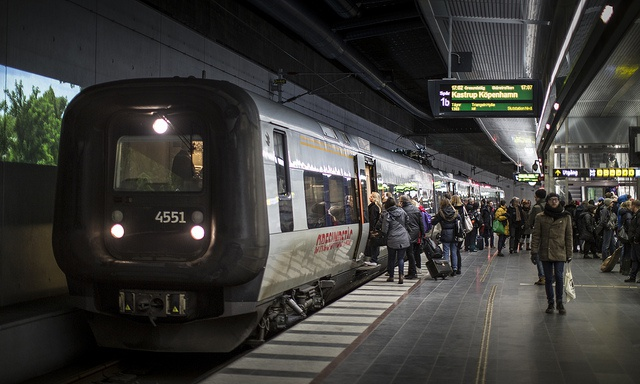Describe the objects in this image and their specific colors. I can see train in black, gray, darkgray, and lightgray tones, people in black, gray, and darkgray tones, people in black and gray tones, people in black, gray, and darkgray tones, and people in black and gray tones in this image. 